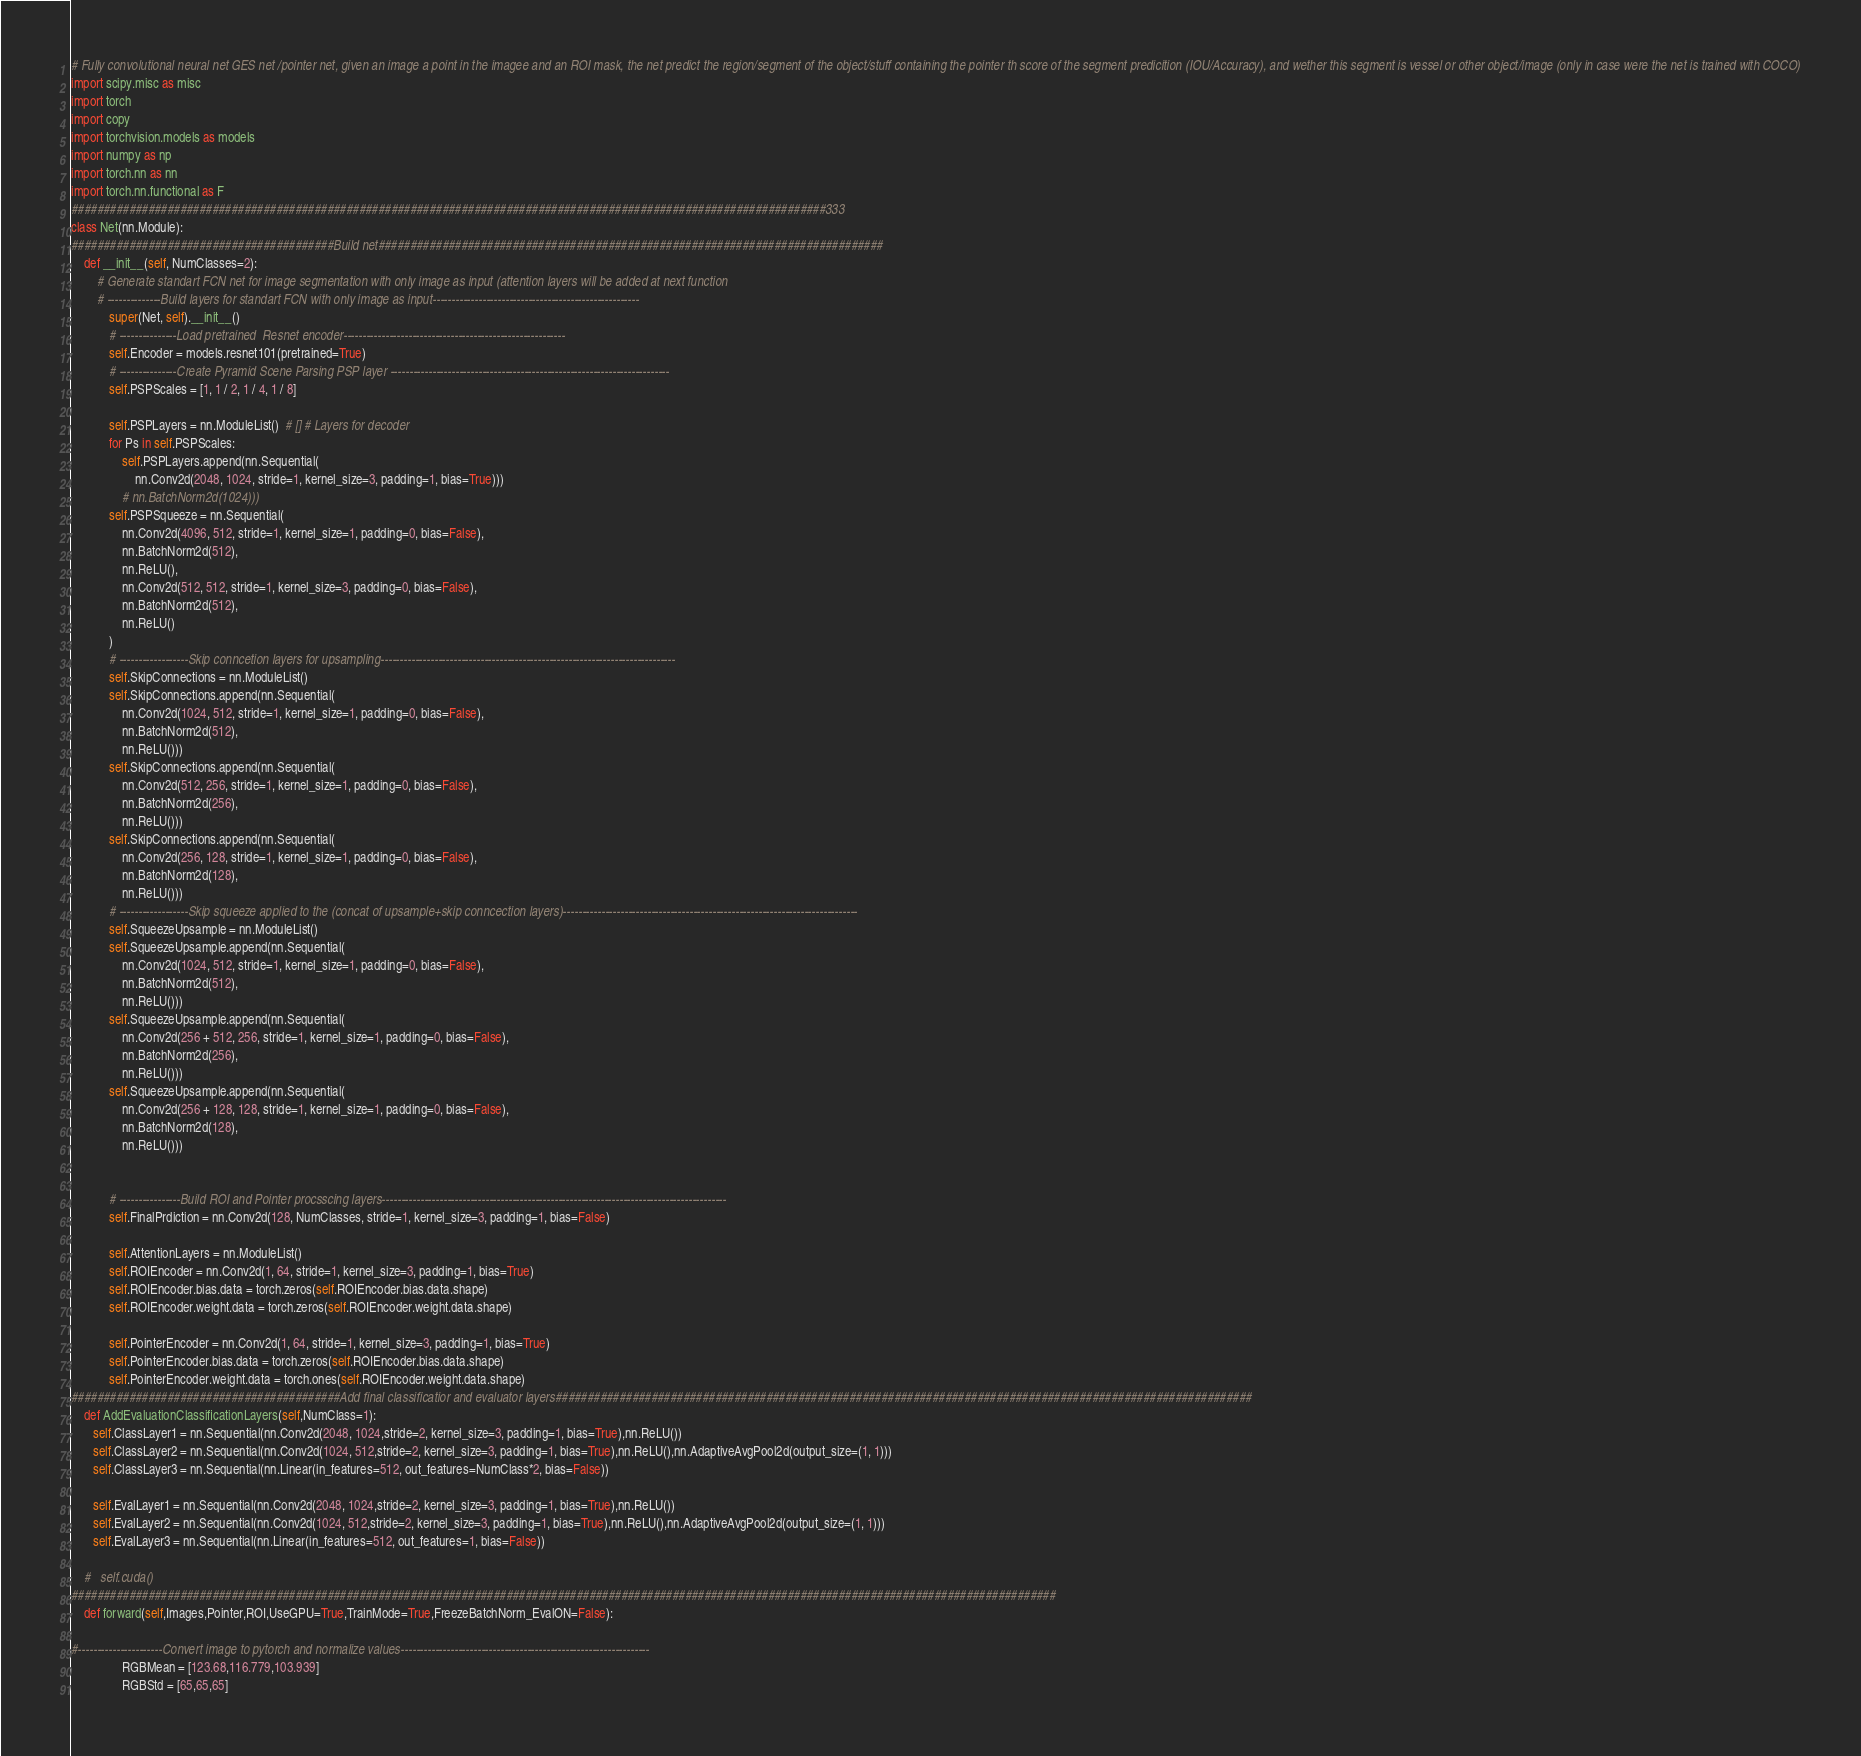Convert code to text. <code><loc_0><loc_0><loc_500><loc_500><_Python_># Fully convolutional neural net GES net /pointer net, given an image a point in the imagee and an ROI mask, the net predict the region/segment of the object/stuff containing the pointer th score of the segment predicition (IOU/Accuracy), and wether this segment is vessel or other object/image (only in case were the net is trained with COCO)
import scipy.misc as misc
import torch
import copy
import torchvision.models as models
import numpy as np
import torch.nn as nn
import torch.nn.functional as F
######################################################################################################################333
class Net(nn.Module):
#########################################Build net###############################################################################
    def __init__(self, NumClasses=2):
        # Generate standart FCN net for image segmentation with only image as input (attention layers will be added at next function
        # --------------Build layers for standart FCN with only image as input------------------------------------------------------
            super(Net, self).__init__()
            # ---------------Load pretrained  Resnet encoder----------------------------------------------------------
            self.Encoder = models.resnet101(pretrained=True)
            # ---------------Create Pyramid Scene Parsing PSP layer -------------------------------------------------------------------------
            self.PSPScales = [1, 1 / 2, 1 / 4, 1 / 8]

            self.PSPLayers = nn.ModuleList()  # [] # Layers for decoder
            for Ps in self.PSPScales:
                self.PSPLayers.append(nn.Sequential(
                    nn.Conv2d(2048, 1024, stride=1, kernel_size=3, padding=1, bias=True)))
                # nn.BatchNorm2d(1024)))
            self.PSPSqueeze = nn.Sequential(
                nn.Conv2d(4096, 512, stride=1, kernel_size=1, padding=0, bias=False),
                nn.BatchNorm2d(512),
                nn.ReLU(),
                nn.Conv2d(512, 512, stride=1, kernel_size=3, padding=0, bias=False),
                nn.BatchNorm2d(512),
                nn.ReLU()
            )
            # ------------------Skip conncetion layers for upsampling-----------------------------------------------------------------------------
            self.SkipConnections = nn.ModuleList()
            self.SkipConnections.append(nn.Sequential(
                nn.Conv2d(1024, 512, stride=1, kernel_size=1, padding=0, bias=False),
                nn.BatchNorm2d(512),
                nn.ReLU()))
            self.SkipConnections.append(nn.Sequential(
                nn.Conv2d(512, 256, stride=1, kernel_size=1, padding=0, bias=False),
                nn.BatchNorm2d(256),
                nn.ReLU()))
            self.SkipConnections.append(nn.Sequential(
                nn.Conv2d(256, 128, stride=1, kernel_size=1, padding=0, bias=False),
                nn.BatchNorm2d(128),
                nn.ReLU()))
            # ------------------Skip squeeze applied to the (concat of upsample+skip conncection layers)-----------------------------------------------------------------------------
            self.SqueezeUpsample = nn.ModuleList()
            self.SqueezeUpsample.append(nn.Sequential(
                nn.Conv2d(1024, 512, stride=1, kernel_size=1, padding=0, bias=False),
                nn.BatchNorm2d(512),
                nn.ReLU()))
            self.SqueezeUpsample.append(nn.Sequential(
                nn.Conv2d(256 + 512, 256, stride=1, kernel_size=1, padding=0, bias=False),
                nn.BatchNorm2d(256),
                nn.ReLU()))
            self.SqueezeUpsample.append(nn.Sequential(
                nn.Conv2d(256 + 128, 128, stride=1, kernel_size=1, padding=0, bias=False),
                nn.BatchNorm2d(128),
                nn.ReLU()))


            # ----------------Build ROI and Pointer procsscing layers------------------------------------------------------------------------------------------
            self.FinalPrdiction = nn.Conv2d(128, NumClasses, stride=1, kernel_size=3, padding=1, bias=False)

            self.AttentionLayers = nn.ModuleList()
            self.ROIEncoder = nn.Conv2d(1, 64, stride=1, kernel_size=3, padding=1, bias=True)
            self.ROIEncoder.bias.data = torch.zeros(self.ROIEncoder.bias.data.shape)
            self.ROIEncoder.weight.data = torch.zeros(self.ROIEncoder.weight.data.shape)

            self.PointerEncoder = nn.Conv2d(1, 64, stride=1, kernel_size=3, padding=1, bias=True)
            self.PointerEncoder.bias.data = torch.zeros(self.ROIEncoder.bias.data.shape)
            self.PointerEncoder.weight.data = torch.ones(self.ROIEncoder.weight.data.shape)
##########################################Add final classificatior and evaluator layers#############################################################################################################
    def AddEvaluationClassificationLayers(self,NumClass=1):
       self.ClassLayer1 = nn.Sequential(nn.Conv2d(2048, 1024,stride=2, kernel_size=3, padding=1, bias=True),nn.ReLU())
       self.ClassLayer2 = nn.Sequential(nn.Conv2d(1024, 512,stride=2, kernel_size=3, padding=1, bias=True),nn.ReLU(),nn.AdaptiveAvgPool2d(output_size=(1, 1)))
       self.ClassLayer3 = nn.Sequential(nn.Linear(in_features=512, out_features=NumClass*2, bias=False))

       self.EvalLayer1 = nn.Sequential(nn.Conv2d(2048, 1024,stride=2, kernel_size=3, padding=1, bias=True),nn.ReLU())
       self.EvalLayer2 = nn.Sequential(nn.Conv2d(1024, 512,stride=2, kernel_size=3, padding=1, bias=True),nn.ReLU(),nn.AdaptiveAvgPool2d(output_size=(1, 1)))
       self.EvalLayer3 = nn.Sequential(nn.Linear(in_features=512, out_features=1, bias=False))

    #   self.cuda()
##########################################################################################################################################################
    def forward(self,Images,Pointer,ROI,UseGPU=True,TrainMode=True,FreezeBatchNorm_EvalON=False):

#----------------------Convert image to pytorch and normalize values-----------------------------------------------------------------
                RGBMean = [123.68,116.779,103.939]
                RGBStd = [65,65,65]</code> 